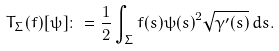<formula> <loc_0><loc_0><loc_500><loc_500>T _ { \Sigma } ( f ) [ \psi ] \colon = \frac { 1 } { 2 } \int _ { \Sigma } f ( s ) \psi { ( s ) } ^ { 2 } \sqrt { \gamma ^ { \prime } ( s ) } \, d s .</formula> 